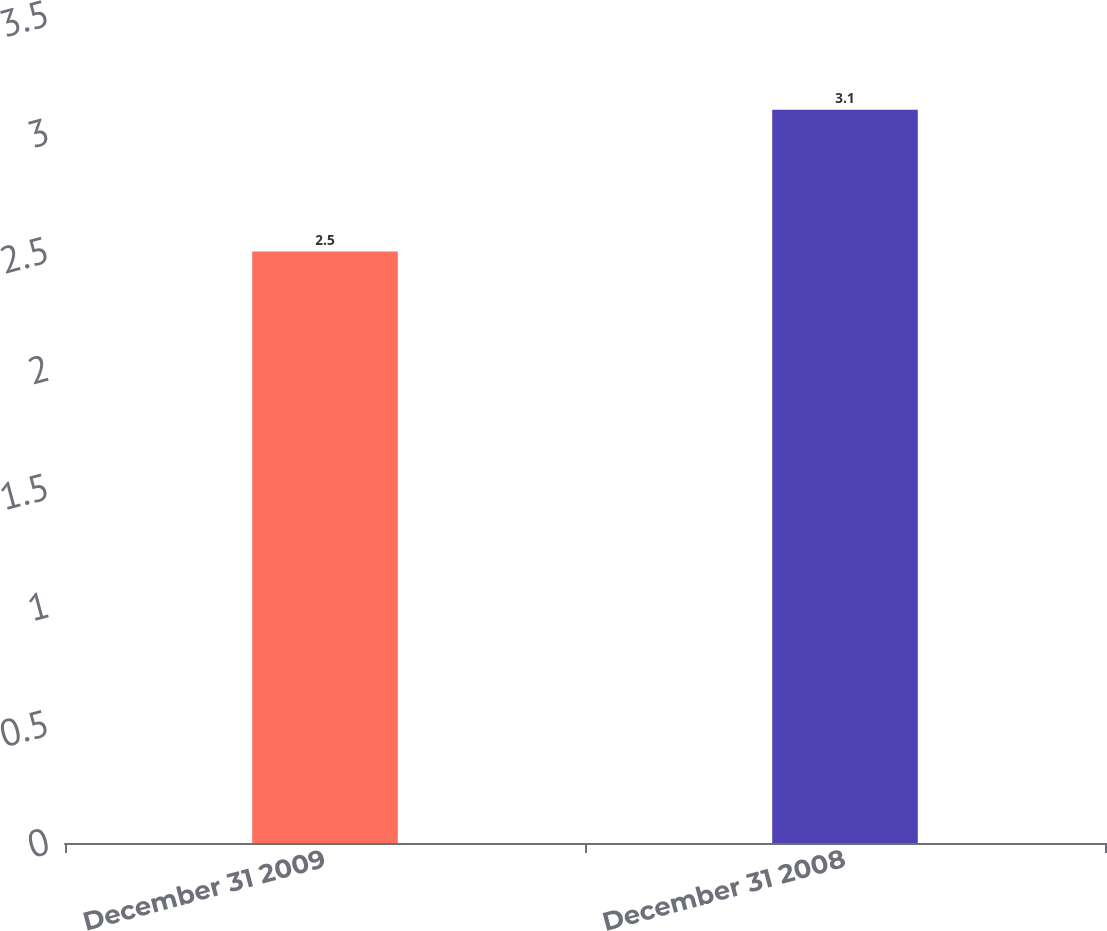<chart> <loc_0><loc_0><loc_500><loc_500><bar_chart><fcel>December 31 2009<fcel>December 31 2008<nl><fcel>2.5<fcel>3.1<nl></chart> 